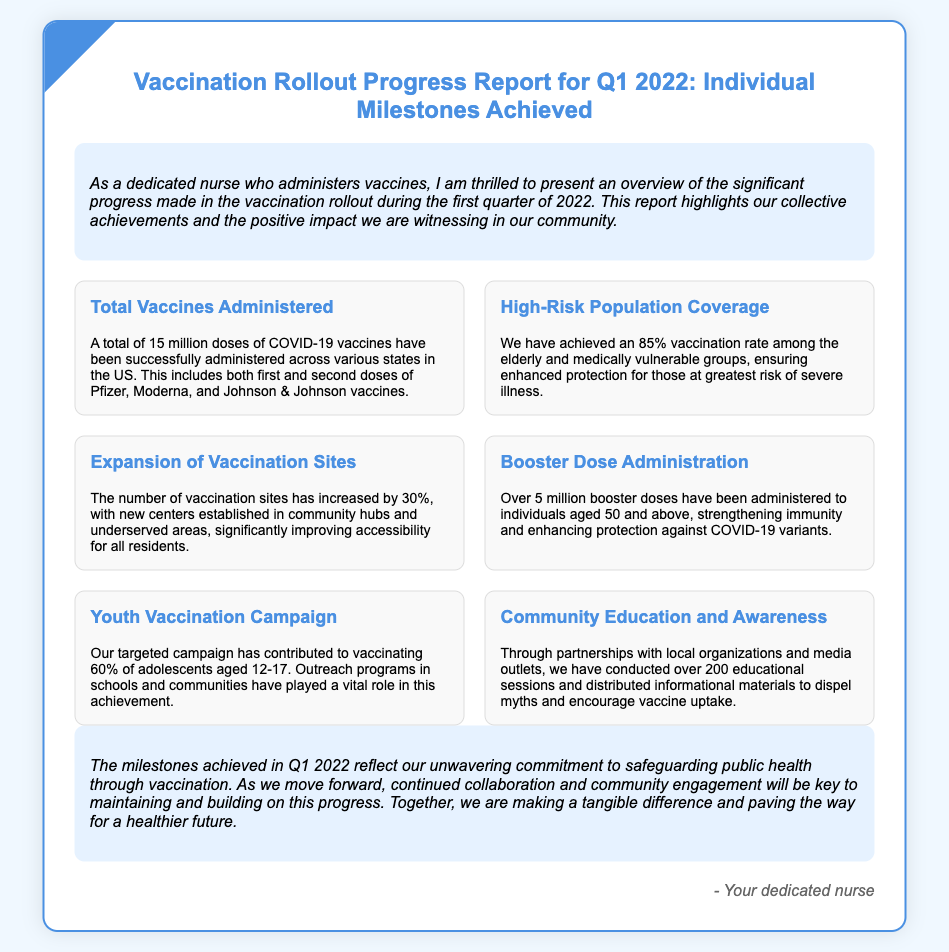what is the total number of doses administered? The report states that a total of 15 million doses of COVID-19 vaccines have been administered.
Answer: 15 million what percentage of high-risk populations are vaccinated? The report mentions that there is an 85% vaccination rate among the elderly and medically vulnerable groups.
Answer: 85% how much has the number of vaccination sites increased? The report indicates that the number of vaccination sites has increased by 30%.
Answer: 30% how many booster doses have been administered? The report states that over 5 million booster doses have been administered to individuals aged 50 and above.
Answer: Over 5 million what percentage of adolescents aged 12-17 have been vaccinated? The report mentions that 60% of adolescents aged 12-17 have been vaccinated.
Answer: 60% how many educational sessions were conducted? The report states that over 200 educational sessions have been conducted to promote vaccine uptake.
Answer: Over 200 what is the main focus of the vaccination rollout in Q1 2022? The focus of the report highlights significant progress in the vaccination rollout during the first quarter of 2022.
Answer: Significant progress who is the intended audience for the report? The report is directed towards individuals interested in the vaccination progress, highlighting the role of a dedicated nurse.
Answer: Individuals interested in vaccination progress 